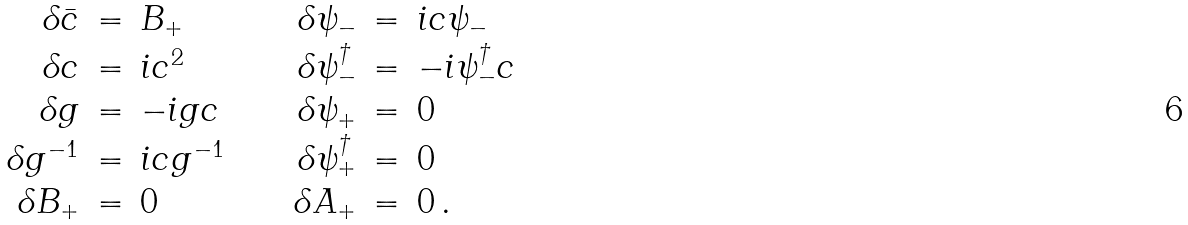<formula> <loc_0><loc_0><loc_500><loc_500>\begin{array} { r c l c r c l } \delta \bar { c } & = & B _ { + } & \quad & \delta \psi _ { - } & = & i c \psi _ { - } \\ \delta c & = & i c ^ { 2 } & \quad & \delta \psi _ { - } ^ { \dag } & = & - i \psi ^ { \dag } _ { - } c \\ \delta g & = & - i g c & \quad & \delta \psi _ { + } & = & 0 \\ \delta g ^ { - 1 } & = & i c g ^ { - 1 } & \quad & \delta \psi _ { + } ^ { \dag } & = & 0 \\ \delta B _ { + } & = & 0 & \quad & \delta A _ { + } & = & 0 \, . \end{array}</formula> 